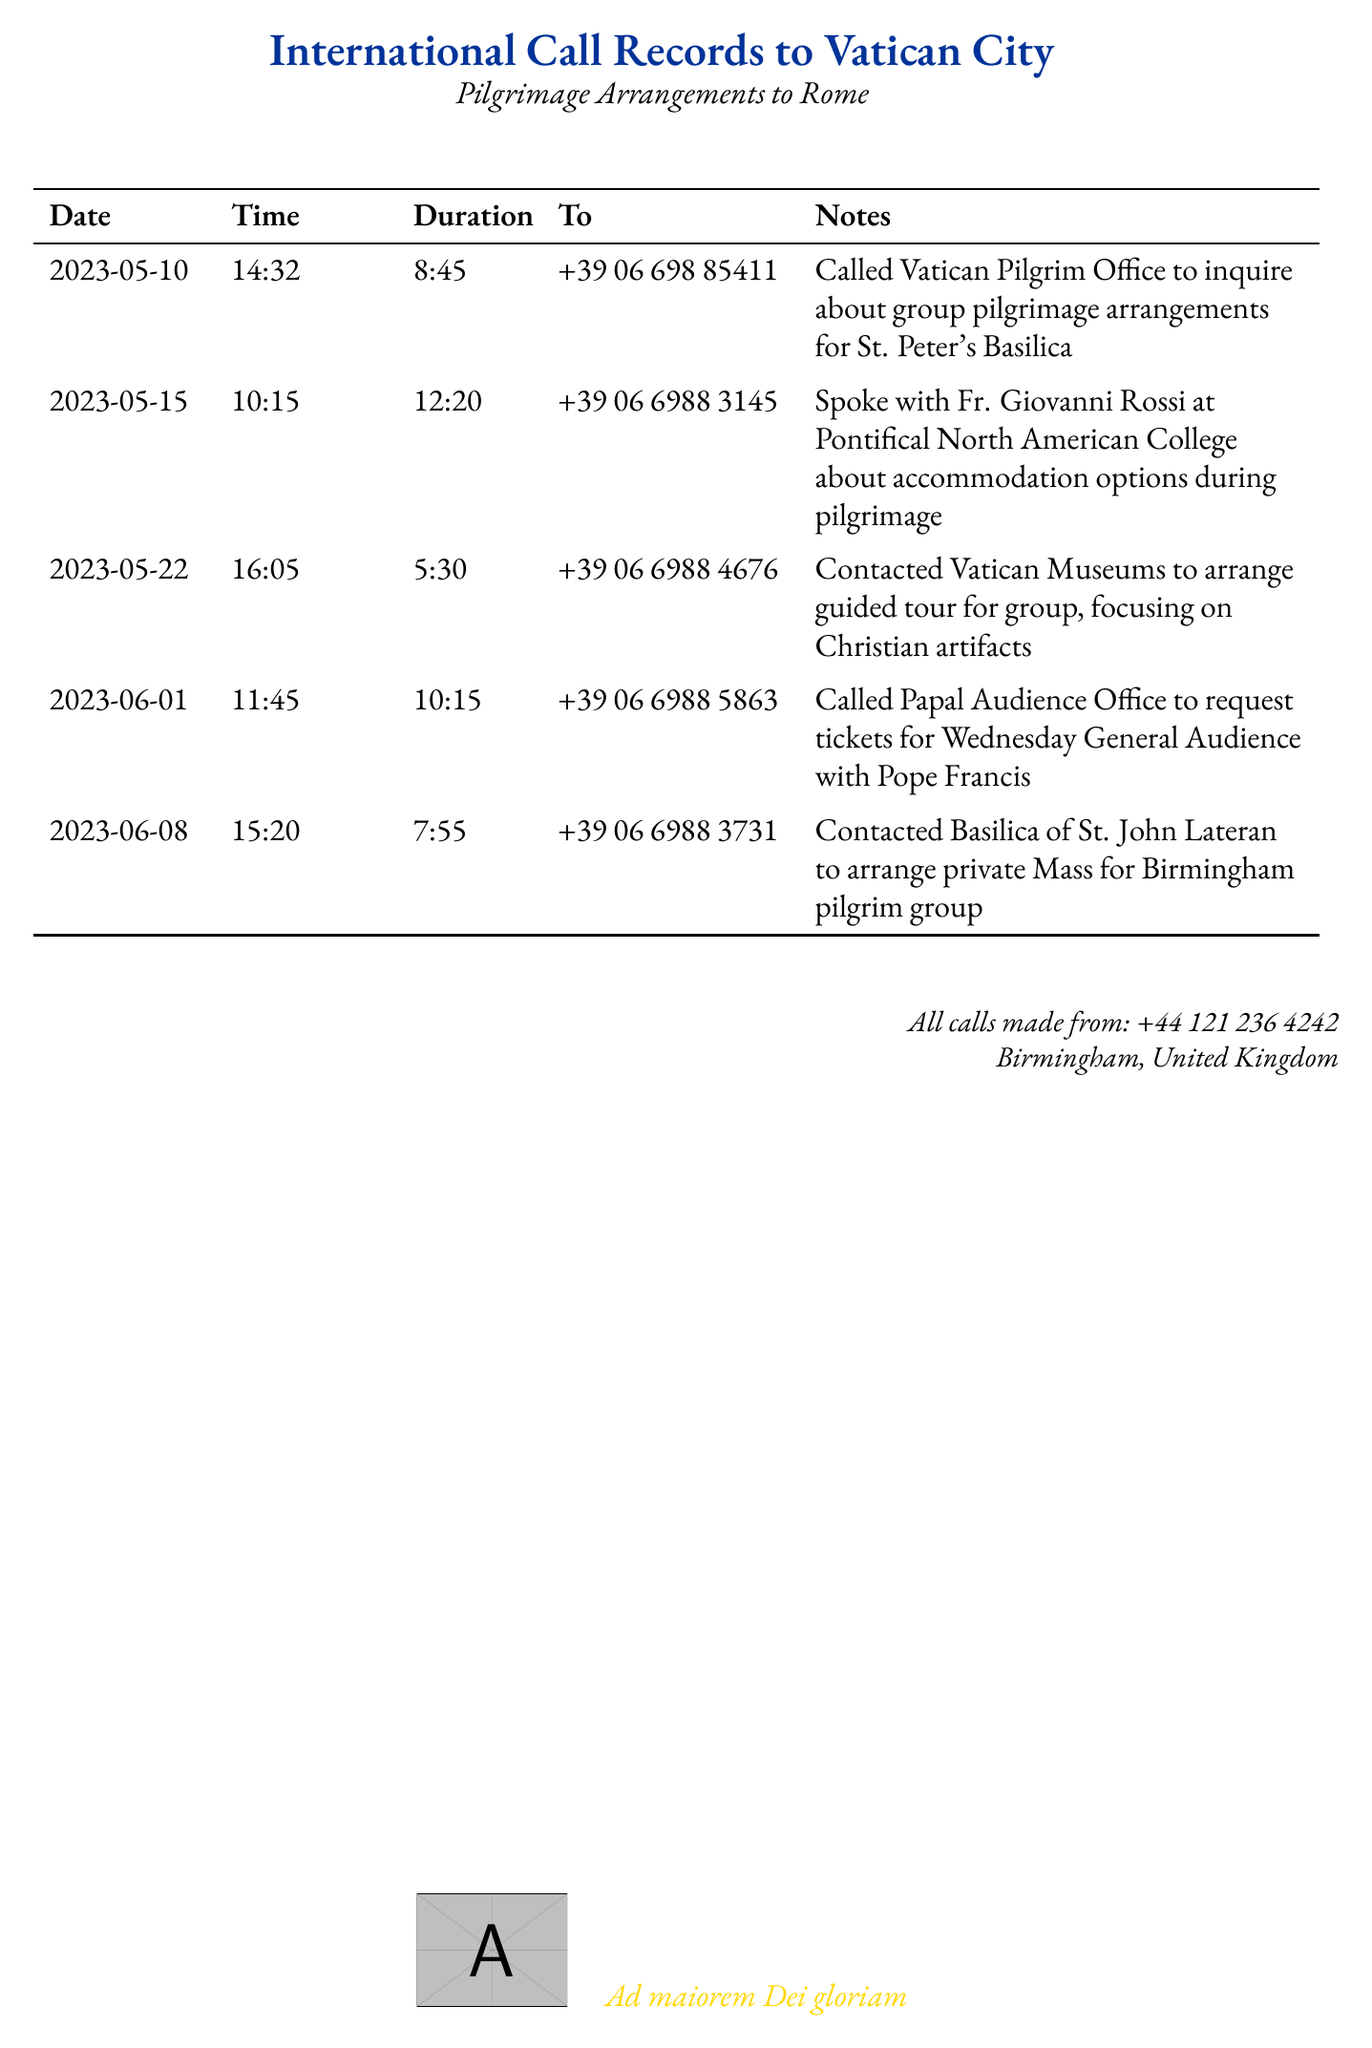What is the date of the first call? The first call recorded in the document was made on May 10, 2023.
Answer: 2023-05-10 Who did the caller speak with on May 15? On May 15, the caller spoke with Fr. Giovanni Rossi.
Answer: Fr. Giovanni Rossi How long did the call to the Vatican Museums last? The call to the Vatican Museums lasted for 5 minutes and 30 seconds.
Answer: 5:30 What was arranged for the Birmingham pilgrim group on June 8? A private Mass was arranged for the Birmingham pilgrim group.
Answer: private Mass What is the phone number called to inquire about group pilgrimage arrangements? The phone number called for group pilgrimage arrangements is +39 06 698 85411.
Answer: +39 06 698 85411 Which office was contacted to request tickets for the General Audience? The Papal Audience Office was contacted for tickets.
Answer: Papal Audience Office On what date was the call to arrange a guided tour made? The call to arrange a guided tour was made on May 22, 2023.
Answer: 2023-05-22 What was the primary focus of the guided tour arranged on May 22? The primary focus of the guided tour was on Christian artifacts.
Answer: Christian artifacts 